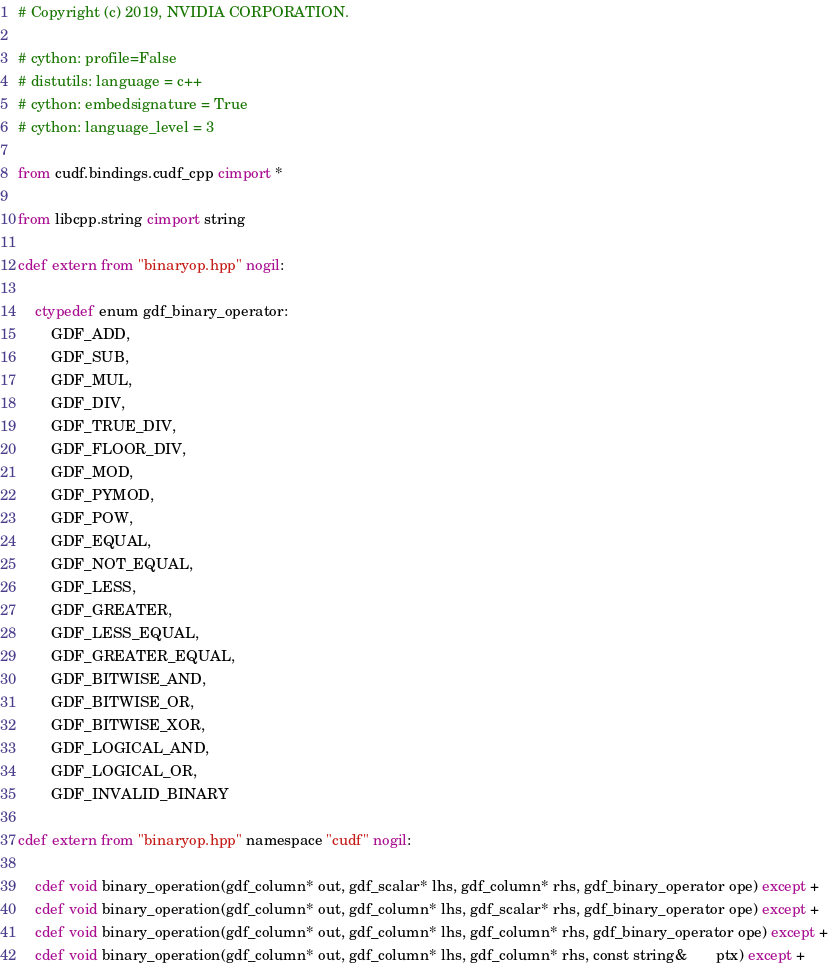<code> <loc_0><loc_0><loc_500><loc_500><_Cython_># Copyright (c) 2019, NVIDIA CORPORATION.

# cython: profile=False
# distutils: language = c++
# cython: embedsignature = True
# cython: language_level = 3

from cudf.bindings.cudf_cpp cimport *

from libcpp.string cimport string

cdef extern from "binaryop.hpp" nogil:

    ctypedef enum gdf_binary_operator:
        GDF_ADD,
        GDF_SUB,
        GDF_MUL,
        GDF_DIV,
        GDF_TRUE_DIV,
        GDF_FLOOR_DIV,
        GDF_MOD,
        GDF_PYMOD,
        GDF_POW,
        GDF_EQUAL,
        GDF_NOT_EQUAL,
        GDF_LESS,
        GDF_GREATER,
        GDF_LESS_EQUAL,
        GDF_GREATER_EQUAL,
        GDF_BITWISE_AND,
        GDF_BITWISE_OR,
        GDF_BITWISE_XOR,
        GDF_LOGICAL_AND,
        GDF_LOGICAL_OR,
        GDF_INVALID_BINARY

cdef extern from "binaryop.hpp" namespace "cudf" nogil:

    cdef void binary_operation(gdf_column* out, gdf_scalar* lhs, gdf_column* rhs, gdf_binary_operator ope) except +
    cdef void binary_operation(gdf_column* out, gdf_column* lhs, gdf_scalar* rhs, gdf_binary_operator ope) except +
    cdef void binary_operation(gdf_column* out, gdf_column* lhs, gdf_column* rhs, gdf_binary_operator ope) except +
    cdef void binary_operation(gdf_column* out, gdf_column* lhs, gdf_column* rhs, const string&       ptx) except +
</code> 